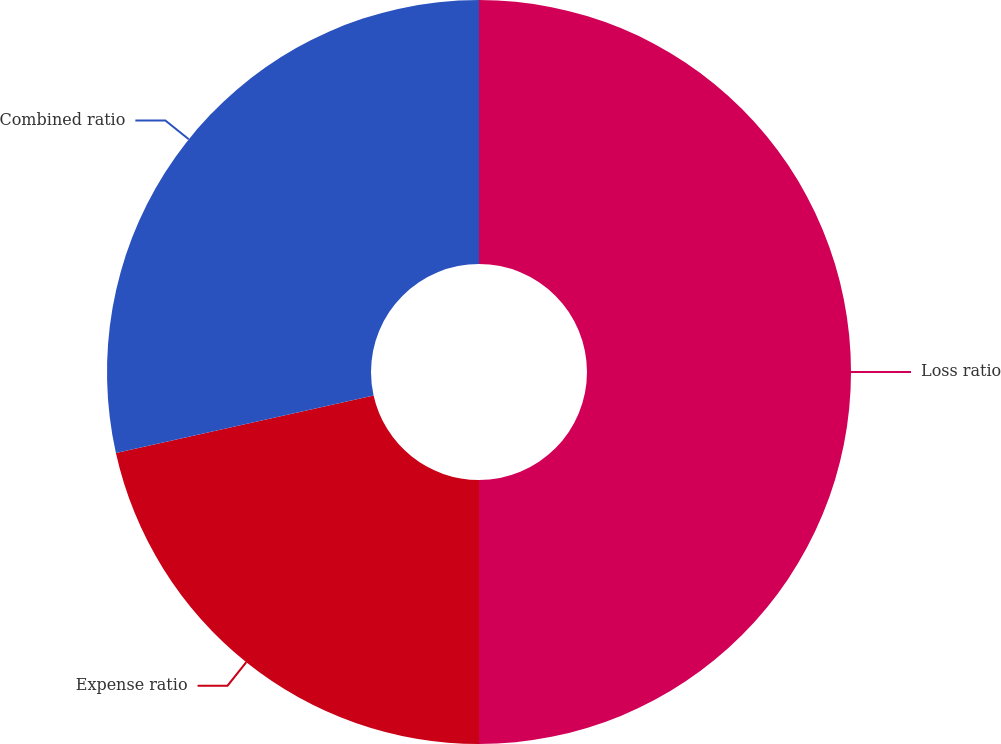<chart> <loc_0><loc_0><loc_500><loc_500><pie_chart><fcel>Loss ratio<fcel>Expense ratio<fcel>Combined ratio<nl><fcel>50.0%<fcel>21.51%<fcel>28.49%<nl></chart> 